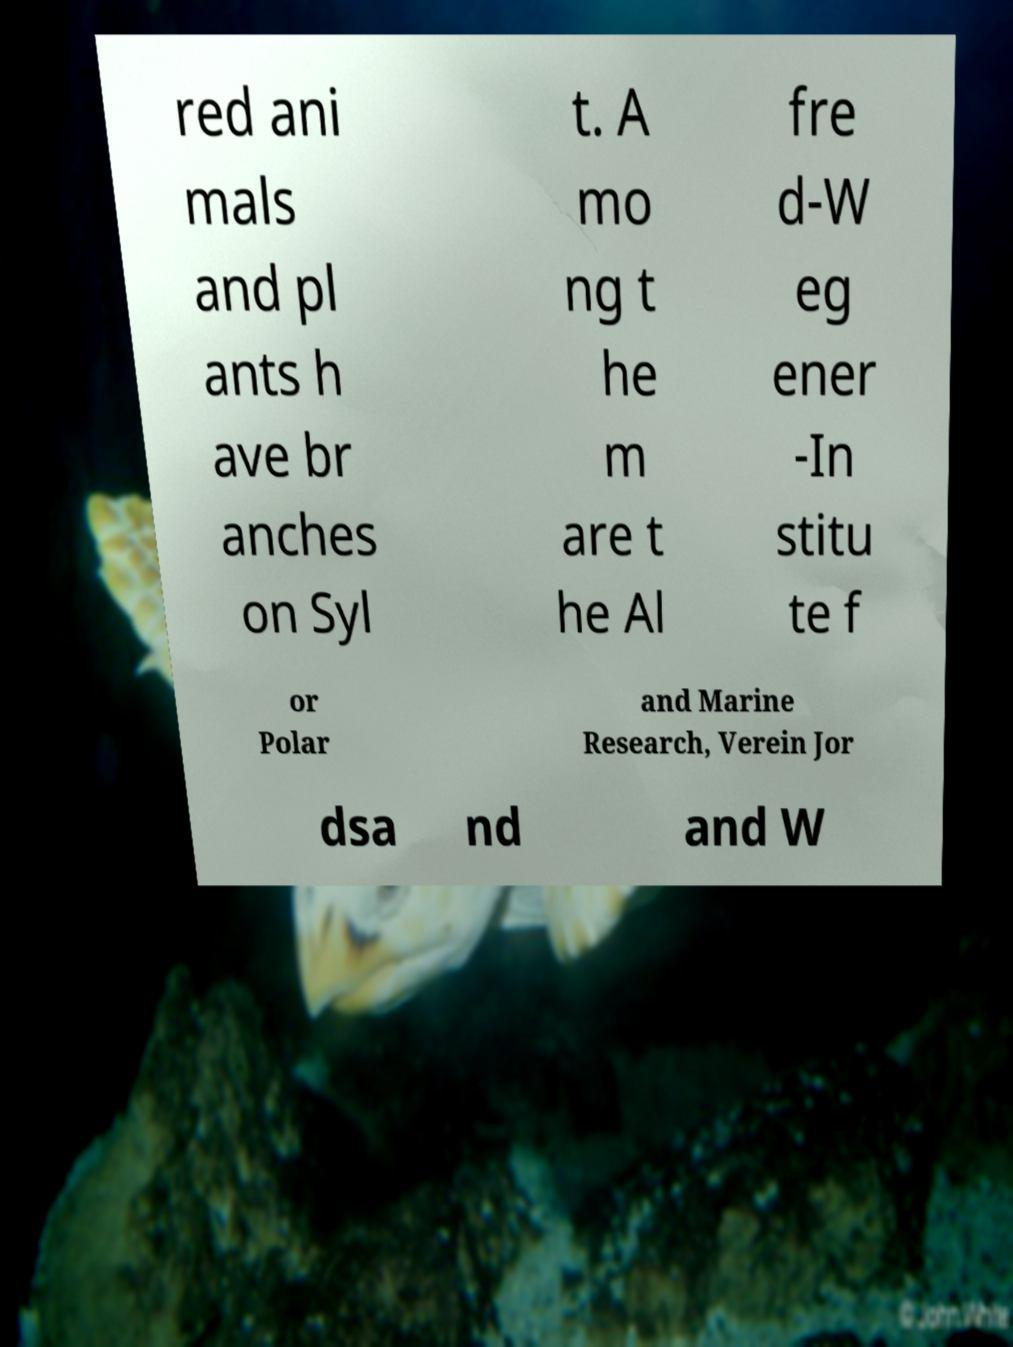Could you assist in decoding the text presented in this image and type it out clearly? red ani mals and pl ants h ave br anches on Syl t. A mo ng t he m are t he Al fre d-W eg ener -In stitu te f or Polar and Marine Research, Verein Jor dsa nd and W 